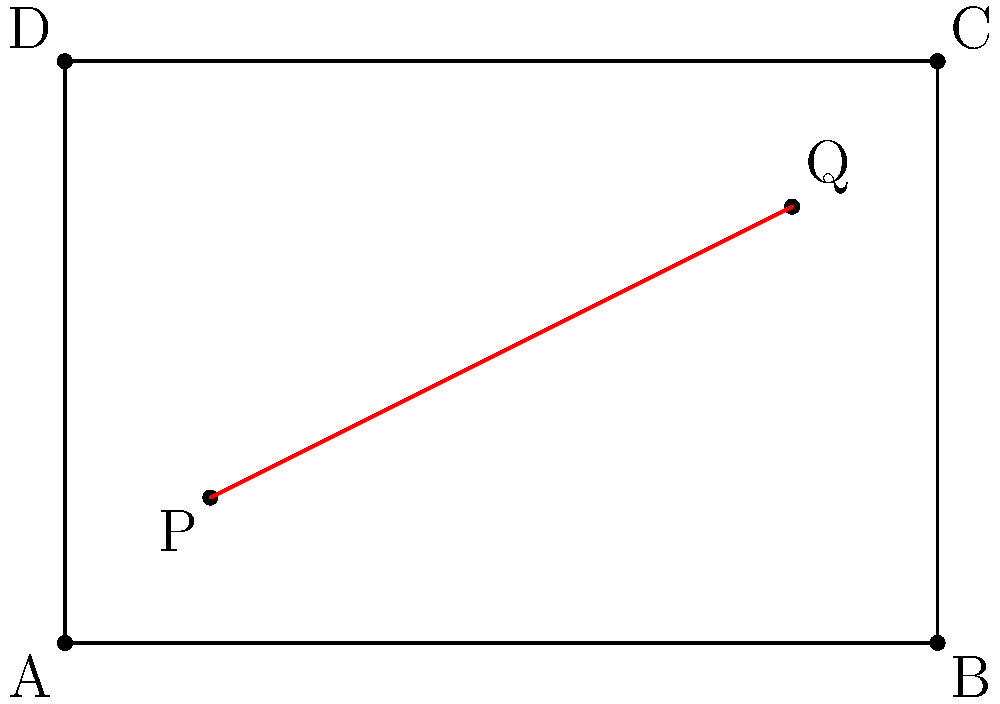You've found a rectangular piece of fabric in a thrift store measuring 6 units wide and 4 units tall. You want to create a diagonal seam from point P (1,1) to point Q (5,3) on the fabric. Calculate the length of this seam to determine how much thread you'll need. To find the length of the seam, we need to calculate the distance between points P and Q. We can use the distance formula derived from the Pythagorean theorem:

1) The distance formula is:
   $$d = \sqrt{(x_2 - x_1)^2 + (y_2 - y_1)^2}$$

2) We have:
   P (1,1) and Q (5,3)
   So, $x_1 = 1$, $y_1 = 1$, $x_2 = 5$, and $y_2 = 3$

3) Let's substitute these values into the formula:
   $$d = \sqrt{(5 - 1)^2 + (3 - 1)^2}$$

4) Simplify inside the parentheses:
   $$d = \sqrt{4^2 + 2^2}$$

5) Calculate the squares:
   $$d = \sqrt{16 + 4}$$

6) Add under the square root:
   $$d = \sqrt{20}$$

7) Simplify the square root:
   $$d = 2\sqrt{5}$$

Therefore, the length of the seam is $2\sqrt{5}$ units.
Answer: $2\sqrt{5}$ units 